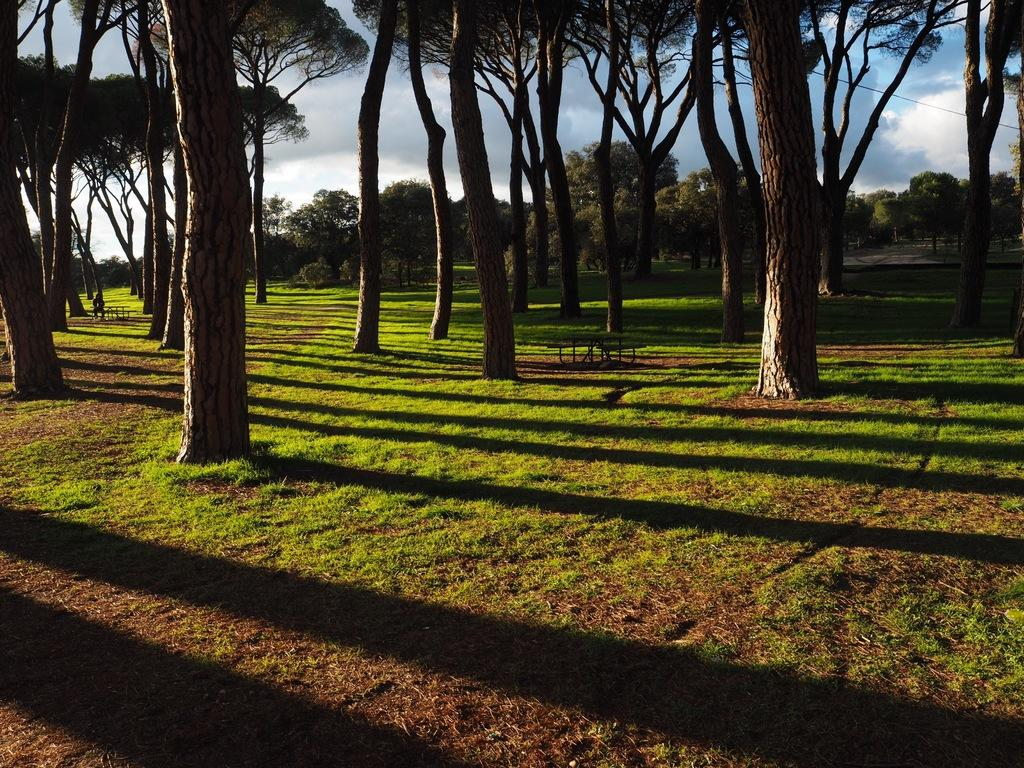What type of vegetation is present on the grassland in the image? There are trees on the grassland in the image. What object can be seen in the middle of the image? There is a bench in the middle of the image. What can be seen in the background of the image? The sky is visible in the background of the image. What type of wheel is visible on the bench in the image? There is no wheel present on the bench in the image. What sign can be seen on the trees in the image? There are no signs visible on the trees in the image. 